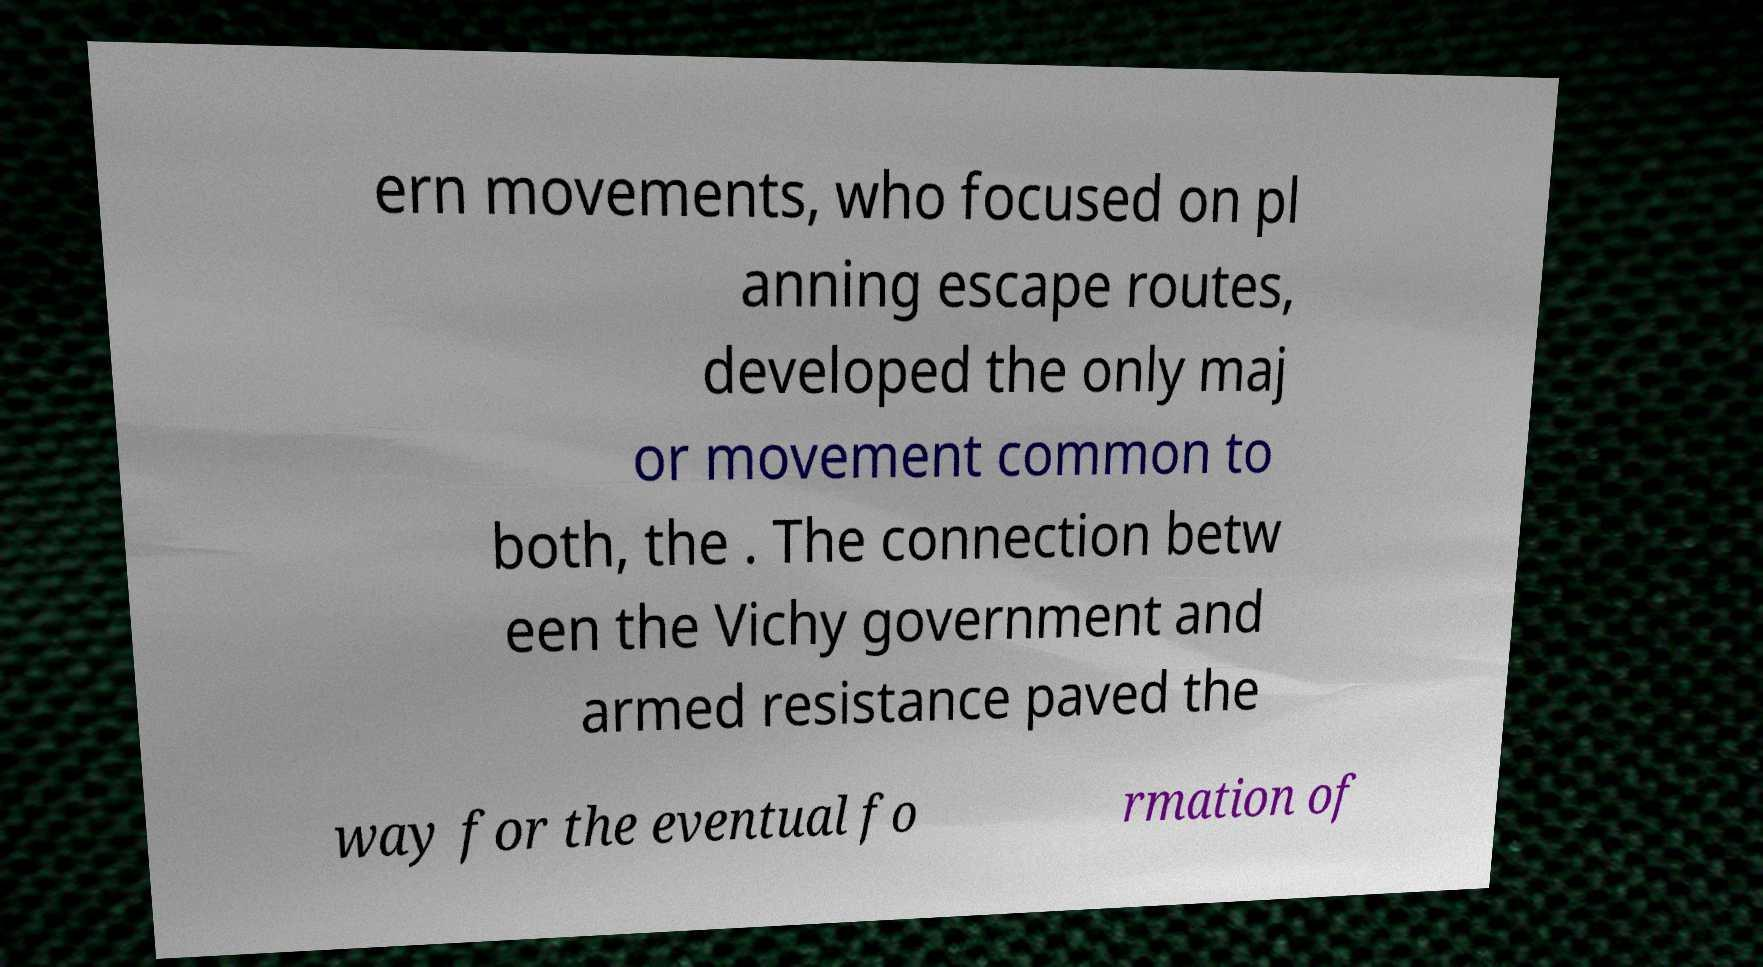Can you accurately transcribe the text from the provided image for me? ern movements, who focused on pl anning escape routes, developed the only maj or movement common to both, the . The connection betw een the Vichy government and armed resistance paved the way for the eventual fo rmation of 